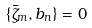<formula> <loc_0><loc_0><loc_500><loc_500>\{ \bar { \zeta } _ { m } , b _ { n } \} = 0</formula> 